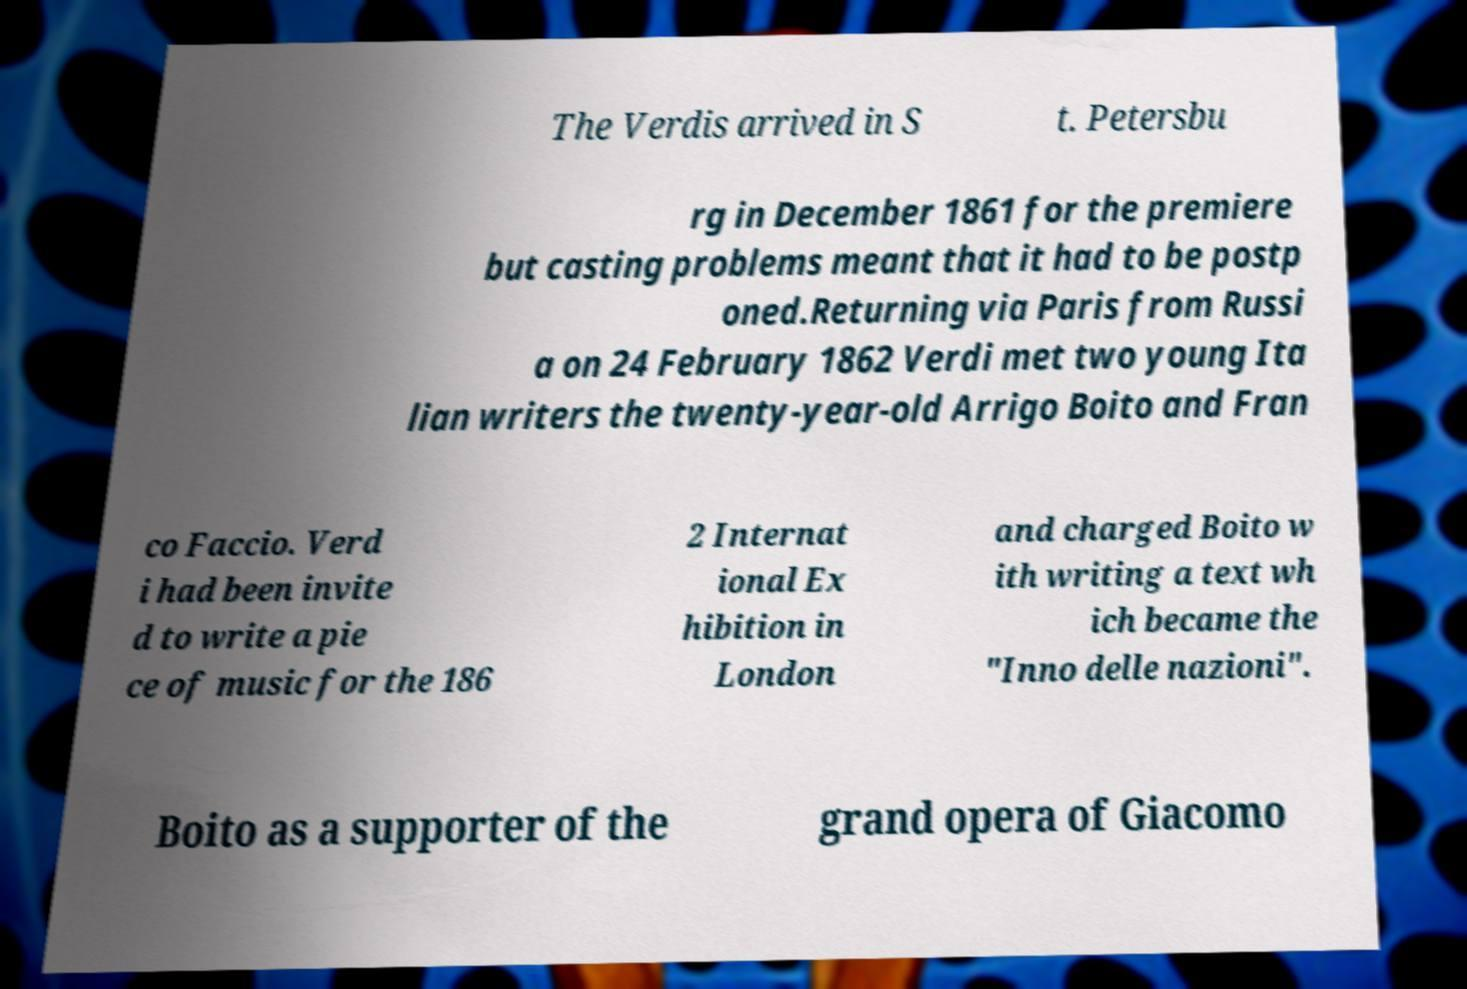I need the written content from this picture converted into text. Can you do that? The Verdis arrived in S t. Petersbu rg in December 1861 for the premiere but casting problems meant that it had to be postp oned.Returning via Paris from Russi a on 24 February 1862 Verdi met two young Ita lian writers the twenty-year-old Arrigo Boito and Fran co Faccio. Verd i had been invite d to write a pie ce of music for the 186 2 Internat ional Ex hibition in London and charged Boito w ith writing a text wh ich became the "Inno delle nazioni". Boito as a supporter of the grand opera of Giacomo 